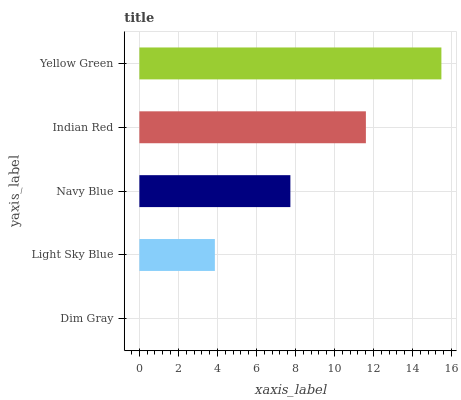Is Dim Gray the minimum?
Answer yes or no. Yes. Is Yellow Green the maximum?
Answer yes or no. Yes. Is Light Sky Blue the minimum?
Answer yes or no. No. Is Light Sky Blue the maximum?
Answer yes or no. No. Is Light Sky Blue greater than Dim Gray?
Answer yes or no. Yes. Is Dim Gray less than Light Sky Blue?
Answer yes or no. Yes. Is Dim Gray greater than Light Sky Blue?
Answer yes or no. No. Is Light Sky Blue less than Dim Gray?
Answer yes or no. No. Is Navy Blue the high median?
Answer yes or no. Yes. Is Navy Blue the low median?
Answer yes or no. Yes. Is Indian Red the high median?
Answer yes or no. No. Is Light Sky Blue the low median?
Answer yes or no. No. 